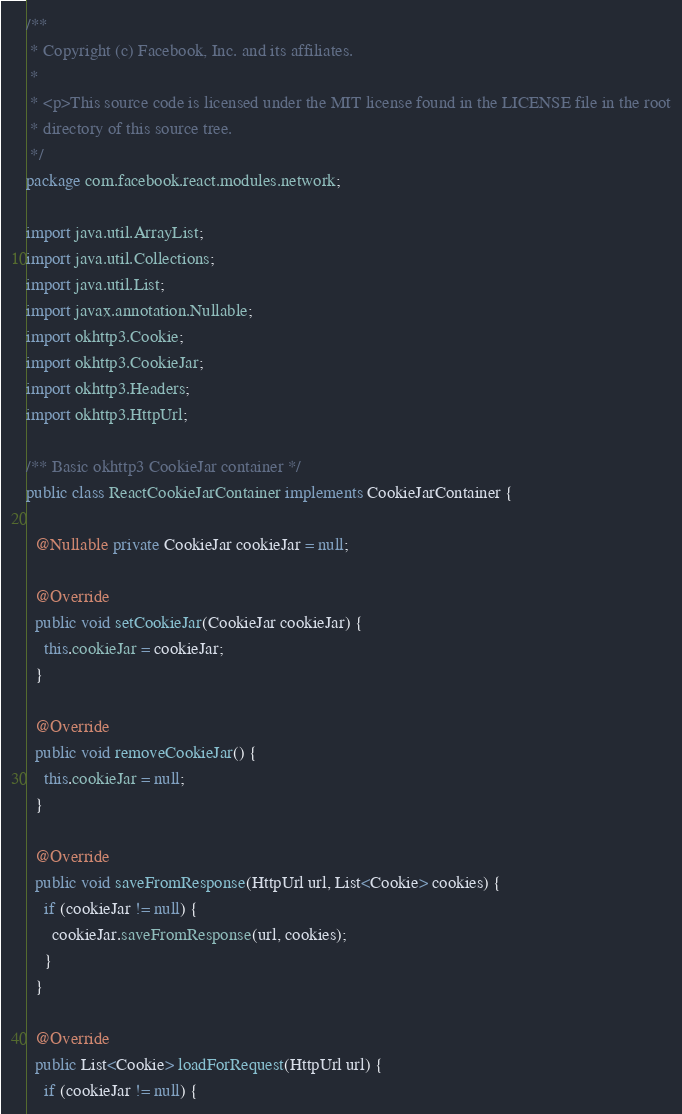<code> <loc_0><loc_0><loc_500><loc_500><_Java_>/**
 * Copyright (c) Facebook, Inc. and its affiliates.
 *
 * <p>This source code is licensed under the MIT license found in the LICENSE file in the root
 * directory of this source tree.
 */
package com.facebook.react.modules.network;

import java.util.ArrayList;
import java.util.Collections;
import java.util.List;
import javax.annotation.Nullable;
import okhttp3.Cookie;
import okhttp3.CookieJar;
import okhttp3.Headers;
import okhttp3.HttpUrl;

/** Basic okhttp3 CookieJar container */
public class ReactCookieJarContainer implements CookieJarContainer {

  @Nullable private CookieJar cookieJar = null;

  @Override
  public void setCookieJar(CookieJar cookieJar) {
    this.cookieJar = cookieJar;
  }

  @Override
  public void removeCookieJar() {
    this.cookieJar = null;
  }

  @Override
  public void saveFromResponse(HttpUrl url, List<Cookie> cookies) {
    if (cookieJar != null) {
      cookieJar.saveFromResponse(url, cookies);
    }
  }

  @Override
  public List<Cookie> loadForRequest(HttpUrl url) {
    if (cookieJar != null) {</code> 